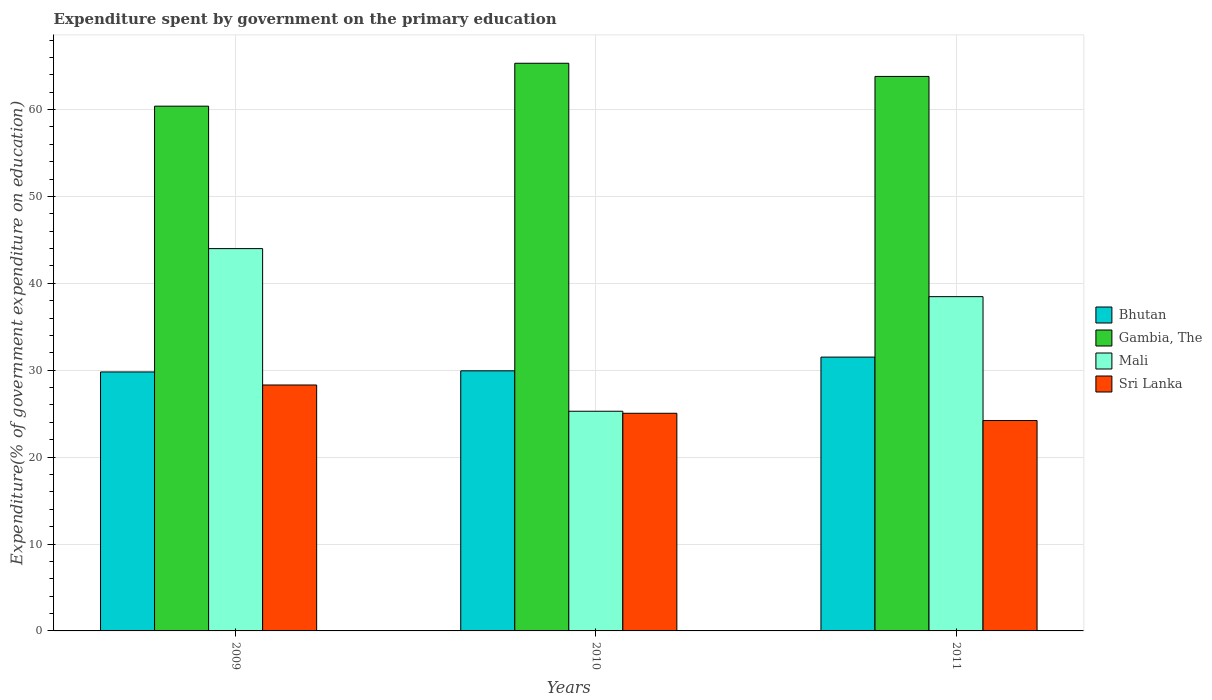Are the number of bars on each tick of the X-axis equal?
Provide a short and direct response. Yes. What is the label of the 2nd group of bars from the left?
Offer a terse response. 2010. In how many cases, is the number of bars for a given year not equal to the number of legend labels?
Provide a short and direct response. 0. What is the expenditure spent by government on the primary education in Gambia, The in 2010?
Give a very brief answer. 65.33. Across all years, what is the maximum expenditure spent by government on the primary education in Gambia, The?
Offer a very short reply. 65.33. Across all years, what is the minimum expenditure spent by government on the primary education in Bhutan?
Keep it short and to the point. 29.8. What is the total expenditure spent by government on the primary education in Bhutan in the graph?
Provide a succinct answer. 91.25. What is the difference between the expenditure spent by government on the primary education in Gambia, The in 2009 and that in 2011?
Offer a very short reply. -3.42. What is the difference between the expenditure spent by government on the primary education in Sri Lanka in 2010 and the expenditure spent by government on the primary education in Gambia, The in 2009?
Your answer should be very brief. -35.34. What is the average expenditure spent by government on the primary education in Mali per year?
Make the answer very short. 35.92. In the year 2009, what is the difference between the expenditure spent by government on the primary education in Gambia, The and expenditure spent by government on the primary education in Bhutan?
Offer a very short reply. 30.59. In how many years, is the expenditure spent by government on the primary education in Sri Lanka greater than 12 %?
Your answer should be very brief. 3. What is the ratio of the expenditure spent by government on the primary education in Sri Lanka in 2009 to that in 2010?
Ensure brevity in your answer.  1.13. Is the expenditure spent by government on the primary education in Gambia, The in 2010 less than that in 2011?
Provide a succinct answer. No. What is the difference between the highest and the second highest expenditure spent by government on the primary education in Bhutan?
Give a very brief answer. 1.58. What is the difference between the highest and the lowest expenditure spent by government on the primary education in Mali?
Provide a short and direct response. 18.72. In how many years, is the expenditure spent by government on the primary education in Mali greater than the average expenditure spent by government on the primary education in Mali taken over all years?
Your response must be concise. 2. Is the sum of the expenditure spent by government on the primary education in Bhutan in 2010 and 2011 greater than the maximum expenditure spent by government on the primary education in Sri Lanka across all years?
Your answer should be compact. Yes. Is it the case that in every year, the sum of the expenditure spent by government on the primary education in Gambia, The and expenditure spent by government on the primary education in Mali is greater than the sum of expenditure spent by government on the primary education in Bhutan and expenditure spent by government on the primary education in Sri Lanka?
Offer a very short reply. Yes. What does the 2nd bar from the left in 2009 represents?
Offer a very short reply. Gambia, The. What does the 4th bar from the right in 2011 represents?
Your response must be concise. Bhutan. Is it the case that in every year, the sum of the expenditure spent by government on the primary education in Sri Lanka and expenditure spent by government on the primary education in Bhutan is greater than the expenditure spent by government on the primary education in Mali?
Provide a succinct answer. Yes. How many years are there in the graph?
Provide a succinct answer. 3. What is the difference between two consecutive major ticks on the Y-axis?
Offer a very short reply. 10. Are the values on the major ticks of Y-axis written in scientific E-notation?
Your answer should be compact. No. Does the graph contain grids?
Your answer should be compact. Yes. How many legend labels are there?
Your response must be concise. 4. What is the title of the graph?
Give a very brief answer. Expenditure spent by government on the primary education. What is the label or title of the X-axis?
Offer a terse response. Years. What is the label or title of the Y-axis?
Offer a terse response. Expenditure(% of government expenditure on education). What is the Expenditure(% of government expenditure on education) of Bhutan in 2009?
Make the answer very short. 29.8. What is the Expenditure(% of government expenditure on education) of Gambia, The in 2009?
Ensure brevity in your answer.  60.39. What is the Expenditure(% of government expenditure on education) in Mali in 2009?
Provide a succinct answer. 44. What is the Expenditure(% of government expenditure on education) in Sri Lanka in 2009?
Ensure brevity in your answer.  28.3. What is the Expenditure(% of government expenditure on education) of Bhutan in 2010?
Offer a very short reply. 29.93. What is the Expenditure(% of government expenditure on education) in Gambia, The in 2010?
Provide a succinct answer. 65.33. What is the Expenditure(% of government expenditure on education) in Mali in 2010?
Your answer should be very brief. 25.28. What is the Expenditure(% of government expenditure on education) in Sri Lanka in 2010?
Keep it short and to the point. 25.05. What is the Expenditure(% of government expenditure on education) of Bhutan in 2011?
Offer a very short reply. 31.51. What is the Expenditure(% of government expenditure on education) of Gambia, The in 2011?
Offer a terse response. 63.81. What is the Expenditure(% of government expenditure on education) in Mali in 2011?
Your answer should be very brief. 38.47. What is the Expenditure(% of government expenditure on education) in Sri Lanka in 2011?
Give a very brief answer. 24.21. Across all years, what is the maximum Expenditure(% of government expenditure on education) in Bhutan?
Provide a short and direct response. 31.51. Across all years, what is the maximum Expenditure(% of government expenditure on education) in Gambia, The?
Ensure brevity in your answer.  65.33. Across all years, what is the maximum Expenditure(% of government expenditure on education) in Mali?
Keep it short and to the point. 44. Across all years, what is the maximum Expenditure(% of government expenditure on education) of Sri Lanka?
Provide a short and direct response. 28.3. Across all years, what is the minimum Expenditure(% of government expenditure on education) of Bhutan?
Give a very brief answer. 29.8. Across all years, what is the minimum Expenditure(% of government expenditure on education) in Gambia, The?
Give a very brief answer. 60.39. Across all years, what is the minimum Expenditure(% of government expenditure on education) in Mali?
Provide a short and direct response. 25.28. Across all years, what is the minimum Expenditure(% of government expenditure on education) in Sri Lanka?
Provide a short and direct response. 24.21. What is the total Expenditure(% of government expenditure on education) of Bhutan in the graph?
Provide a short and direct response. 91.25. What is the total Expenditure(% of government expenditure on education) of Gambia, The in the graph?
Keep it short and to the point. 189.53. What is the total Expenditure(% of government expenditure on education) in Mali in the graph?
Offer a very short reply. 107.75. What is the total Expenditure(% of government expenditure on education) of Sri Lanka in the graph?
Make the answer very short. 77.56. What is the difference between the Expenditure(% of government expenditure on education) of Bhutan in 2009 and that in 2010?
Ensure brevity in your answer.  -0.13. What is the difference between the Expenditure(% of government expenditure on education) of Gambia, The in 2009 and that in 2010?
Your answer should be very brief. -4.94. What is the difference between the Expenditure(% of government expenditure on education) in Mali in 2009 and that in 2010?
Ensure brevity in your answer.  18.72. What is the difference between the Expenditure(% of government expenditure on education) in Sri Lanka in 2009 and that in 2010?
Your response must be concise. 3.25. What is the difference between the Expenditure(% of government expenditure on education) of Bhutan in 2009 and that in 2011?
Ensure brevity in your answer.  -1.71. What is the difference between the Expenditure(% of government expenditure on education) of Gambia, The in 2009 and that in 2011?
Provide a short and direct response. -3.42. What is the difference between the Expenditure(% of government expenditure on education) in Mali in 2009 and that in 2011?
Make the answer very short. 5.53. What is the difference between the Expenditure(% of government expenditure on education) in Sri Lanka in 2009 and that in 2011?
Give a very brief answer. 4.09. What is the difference between the Expenditure(% of government expenditure on education) of Bhutan in 2010 and that in 2011?
Your answer should be very brief. -1.58. What is the difference between the Expenditure(% of government expenditure on education) in Gambia, The in 2010 and that in 2011?
Provide a short and direct response. 1.52. What is the difference between the Expenditure(% of government expenditure on education) in Mali in 2010 and that in 2011?
Provide a short and direct response. -13.19. What is the difference between the Expenditure(% of government expenditure on education) in Sri Lanka in 2010 and that in 2011?
Ensure brevity in your answer.  0.83. What is the difference between the Expenditure(% of government expenditure on education) of Bhutan in 2009 and the Expenditure(% of government expenditure on education) of Gambia, The in 2010?
Make the answer very short. -35.52. What is the difference between the Expenditure(% of government expenditure on education) of Bhutan in 2009 and the Expenditure(% of government expenditure on education) of Mali in 2010?
Provide a short and direct response. 4.52. What is the difference between the Expenditure(% of government expenditure on education) in Bhutan in 2009 and the Expenditure(% of government expenditure on education) in Sri Lanka in 2010?
Keep it short and to the point. 4.76. What is the difference between the Expenditure(% of government expenditure on education) of Gambia, The in 2009 and the Expenditure(% of government expenditure on education) of Mali in 2010?
Provide a short and direct response. 35.11. What is the difference between the Expenditure(% of government expenditure on education) in Gambia, The in 2009 and the Expenditure(% of government expenditure on education) in Sri Lanka in 2010?
Offer a terse response. 35.34. What is the difference between the Expenditure(% of government expenditure on education) of Mali in 2009 and the Expenditure(% of government expenditure on education) of Sri Lanka in 2010?
Offer a terse response. 18.95. What is the difference between the Expenditure(% of government expenditure on education) of Bhutan in 2009 and the Expenditure(% of government expenditure on education) of Gambia, The in 2011?
Your response must be concise. -34.01. What is the difference between the Expenditure(% of government expenditure on education) in Bhutan in 2009 and the Expenditure(% of government expenditure on education) in Mali in 2011?
Offer a very short reply. -8.66. What is the difference between the Expenditure(% of government expenditure on education) in Bhutan in 2009 and the Expenditure(% of government expenditure on education) in Sri Lanka in 2011?
Provide a succinct answer. 5.59. What is the difference between the Expenditure(% of government expenditure on education) of Gambia, The in 2009 and the Expenditure(% of government expenditure on education) of Mali in 2011?
Make the answer very short. 21.92. What is the difference between the Expenditure(% of government expenditure on education) of Gambia, The in 2009 and the Expenditure(% of government expenditure on education) of Sri Lanka in 2011?
Keep it short and to the point. 36.18. What is the difference between the Expenditure(% of government expenditure on education) in Mali in 2009 and the Expenditure(% of government expenditure on education) in Sri Lanka in 2011?
Your answer should be very brief. 19.78. What is the difference between the Expenditure(% of government expenditure on education) in Bhutan in 2010 and the Expenditure(% of government expenditure on education) in Gambia, The in 2011?
Provide a short and direct response. -33.88. What is the difference between the Expenditure(% of government expenditure on education) of Bhutan in 2010 and the Expenditure(% of government expenditure on education) of Mali in 2011?
Your answer should be compact. -8.54. What is the difference between the Expenditure(% of government expenditure on education) of Bhutan in 2010 and the Expenditure(% of government expenditure on education) of Sri Lanka in 2011?
Provide a short and direct response. 5.72. What is the difference between the Expenditure(% of government expenditure on education) in Gambia, The in 2010 and the Expenditure(% of government expenditure on education) in Mali in 2011?
Your answer should be very brief. 26.86. What is the difference between the Expenditure(% of government expenditure on education) of Gambia, The in 2010 and the Expenditure(% of government expenditure on education) of Sri Lanka in 2011?
Provide a short and direct response. 41.12. What is the difference between the Expenditure(% of government expenditure on education) of Mali in 2010 and the Expenditure(% of government expenditure on education) of Sri Lanka in 2011?
Provide a short and direct response. 1.07. What is the average Expenditure(% of government expenditure on education) in Bhutan per year?
Provide a short and direct response. 30.42. What is the average Expenditure(% of government expenditure on education) of Gambia, The per year?
Make the answer very short. 63.18. What is the average Expenditure(% of government expenditure on education) of Mali per year?
Offer a very short reply. 35.92. What is the average Expenditure(% of government expenditure on education) in Sri Lanka per year?
Offer a terse response. 25.85. In the year 2009, what is the difference between the Expenditure(% of government expenditure on education) of Bhutan and Expenditure(% of government expenditure on education) of Gambia, The?
Provide a short and direct response. -30.59. In the year 2009, what is the difference between the Expenditure(% of government expenditure on education) in Bhutan and Expenditure(% of government expenditure on education) in Mali?
Ensure brevity in your answer.  -14.19. In the year 2009, what is the difference between the Expenditure(% of government expenditure on education) of Bhutan and Expenditure(% of government expenditure on education) of Sri Lanka?
Make the answer very short. 1.5. In the year 2009, what is the difference between the Expenditure(% of government expenditure on education) of Gambia, The and Expenditure(% of government expenditure on education) of Mali?
Your answer should be compact. 16.39. In the year 2009, what is the difference between the Expenditure(% of government expenditure on education) in Gambia, The and Expenditure(% of government expenditure on education) in Sri Lanka?
Provide a succinct answer. 32.09. In the year 2009, what is the difference between the Expenditure(% of government expenditure on education) in Mali and Expenditure(% of government expenditure on education) in Sri Lanka?
Make the answer very short. 15.7. In the year 2010, what is the difference between the Expenditure(% of government expenditure on education) of Bhutan and Expenditure(% of government expenditure on education) of Gambia, The?
Offer a very short reply. -35.4. In the year 2010, what is the difference between the Expenditure(% of government expenditure on education) of Bhutan and Expenditure(% of government expenditure on education) of Mali?
Make the answer very short. 4.65. In the year 2010, what is the difference between the Expenditure(% of government expenditure on education) of Bhutan and Expenditure(% of government expenditure on education) of Sri Lanka?
Provide a succinct answer. 4.89. In the year 2010, what is the difference between the Expenditure(% of government expenditure on education) in Gambia, The and Expenditure(% of government expenditure on education) in Mali?
Ensure brevity in your answer.  40.05. In the year 2010, what is the difference between the Expenditure(% of government expenditure on education) of Gambia, The and Expenditure(% of government expenditure on education) of Sri Lanka?
Make the answer very short. 40.28. In the year 2010, what is the difference between the Expenditure(% of government expenditure on education) in Mali and Expenditure(% of government expenditure on education) in Sri Lanka?
Provide a succinct answer. 0.23. In the year 2011, what is the difference between the Expenditure(% of government expenditure on education) in Bhutan and Expenditure(% of government expenditure on education) in Gambia, The?
Keep it short and to the point. -32.3. In the year 2011, what is the difference between the Expenditure(% of government expenditure on education) in Bhutan and Expenditure(% of government expenditure on education) in Mali?
Your response must be concise. -6.96. In the year 2011, what is the difference between the Expenditure(% of government expenditure on education) in Bhutan and Expenditure(% of government expenditure on education) in Sri Lanka?
Give a very brief answer. 7.3. In the year 2011, what is the difference between the Expenditure(% of government expenditure on education) of Gambia, The and Expenditure(% of government expenditure on education) of Mali?
Your answer should be very brief. 25.34. In the year 2011, what is the difference between the Expenditure(% of government expenditure on education) of Gambia, The and Expenditure(% of government expenditure on education) of Sri Lanka?
Make the answer very short. 39.6. In the year 2011, what is the difference between the Expenditure(% of government expenditure on education) in Mali and Expenditure(% of government expenditure on education) in Sri Lanka?
Keep it short and to the point. 14.26. What is the ratio of the Expenditure(% of government expenditure on education) of Bhutan in 2009 to that in 2010?
Make the answer very short. 1. What is the ratio of the Expenditure(% of government expenditure on education) of Gambia, The in 2009 to that in 2010?
Your answer should be compact. 0.92. What is the ratio of the Expenditure(% of government expenditure on education) in Mali in 2009 to that in 2010?
Your answer should be very brief. 1.74. What is the ratio of the Expenditure(% of government expenditure on education) of Sri Lanka in 2009 to that in 2010?
Offer a very short reply. 1.13. What is the ratio of the Expenditure(% of government expenditure on education) in Bhutan in 2009 to that in 2011?
Ensure brevity in your answer.  0.95. What is the ratio of the Expenditure(% of government expenditure on education) in Gambia, The in 2009 to that in 2011?
Your response must be concise. 0.95. What is the ratio of the Expenditure(% of government expenditure on education) of Mali in 2009 to that in 2011?
Your answer should be compact. 1.14. What is the ratio of the Expenditure(% of government expenditure on education) of Sri Lanka in 2009 to that in 2011?
Your response must be concise. 1.17. What is the ratio of the Expenditure(% of government expenditure on education) of Bhutan in 2010 to that in 2011?
Your answer should be compact. 0.95. What is the ratio of the Expenditure(% of government expenditure on education) in Gambia, The in 2010 to that in 2011?
Ensure brevity in your answer.  1.02. What is the ratio of the Expenditure(% of government expenditure on education) of Mali in 2010 to that in 2011?
Make the answer very short. 0.66. What is the ratio of the Expenditure(% of government expenditure on education) in Sri Lanka in 2010 to that in 2011?
Make the answer very short. 1.03. What is the difference between the highest and the second highest Expenditure(% of government expenditure on education) in Bhutan?
Keep it short and to the point. 1.58. What is the difference between the highest and the second highest Expenditure(% of government expenditure on education) in Gambia, The?
Your answer should be very brief. 1.52. What is the difference between the highest and the second highest Expenditure(% of government expenditure on education) of Mali?
Your answer should be compact. 5.53. What is the difference between the highest and the second highest Expenditure(% of government expenditure on education) in Sri Lanka?
Offer a terse response. 3.25. What is the difference between the highest and the lowest Expenditure(% of government expenditure on education) in Bhutan?
Your answer should be compact. 1.71. What is the difference between the highest and the lowest Expenditure(% of government expenditure on education) of Gambia, The?
Your answer should be compact. 4.94. What is the difference between the highest and the lowest Expenditure(% of government expenditure on education) in Mali?
Offer a terse response. 18.72. What is the difference between the highest and the lowest Expenditure(% of government expenditure on education) in Sri Lanka?
Offer a very short reply. 4.09. 